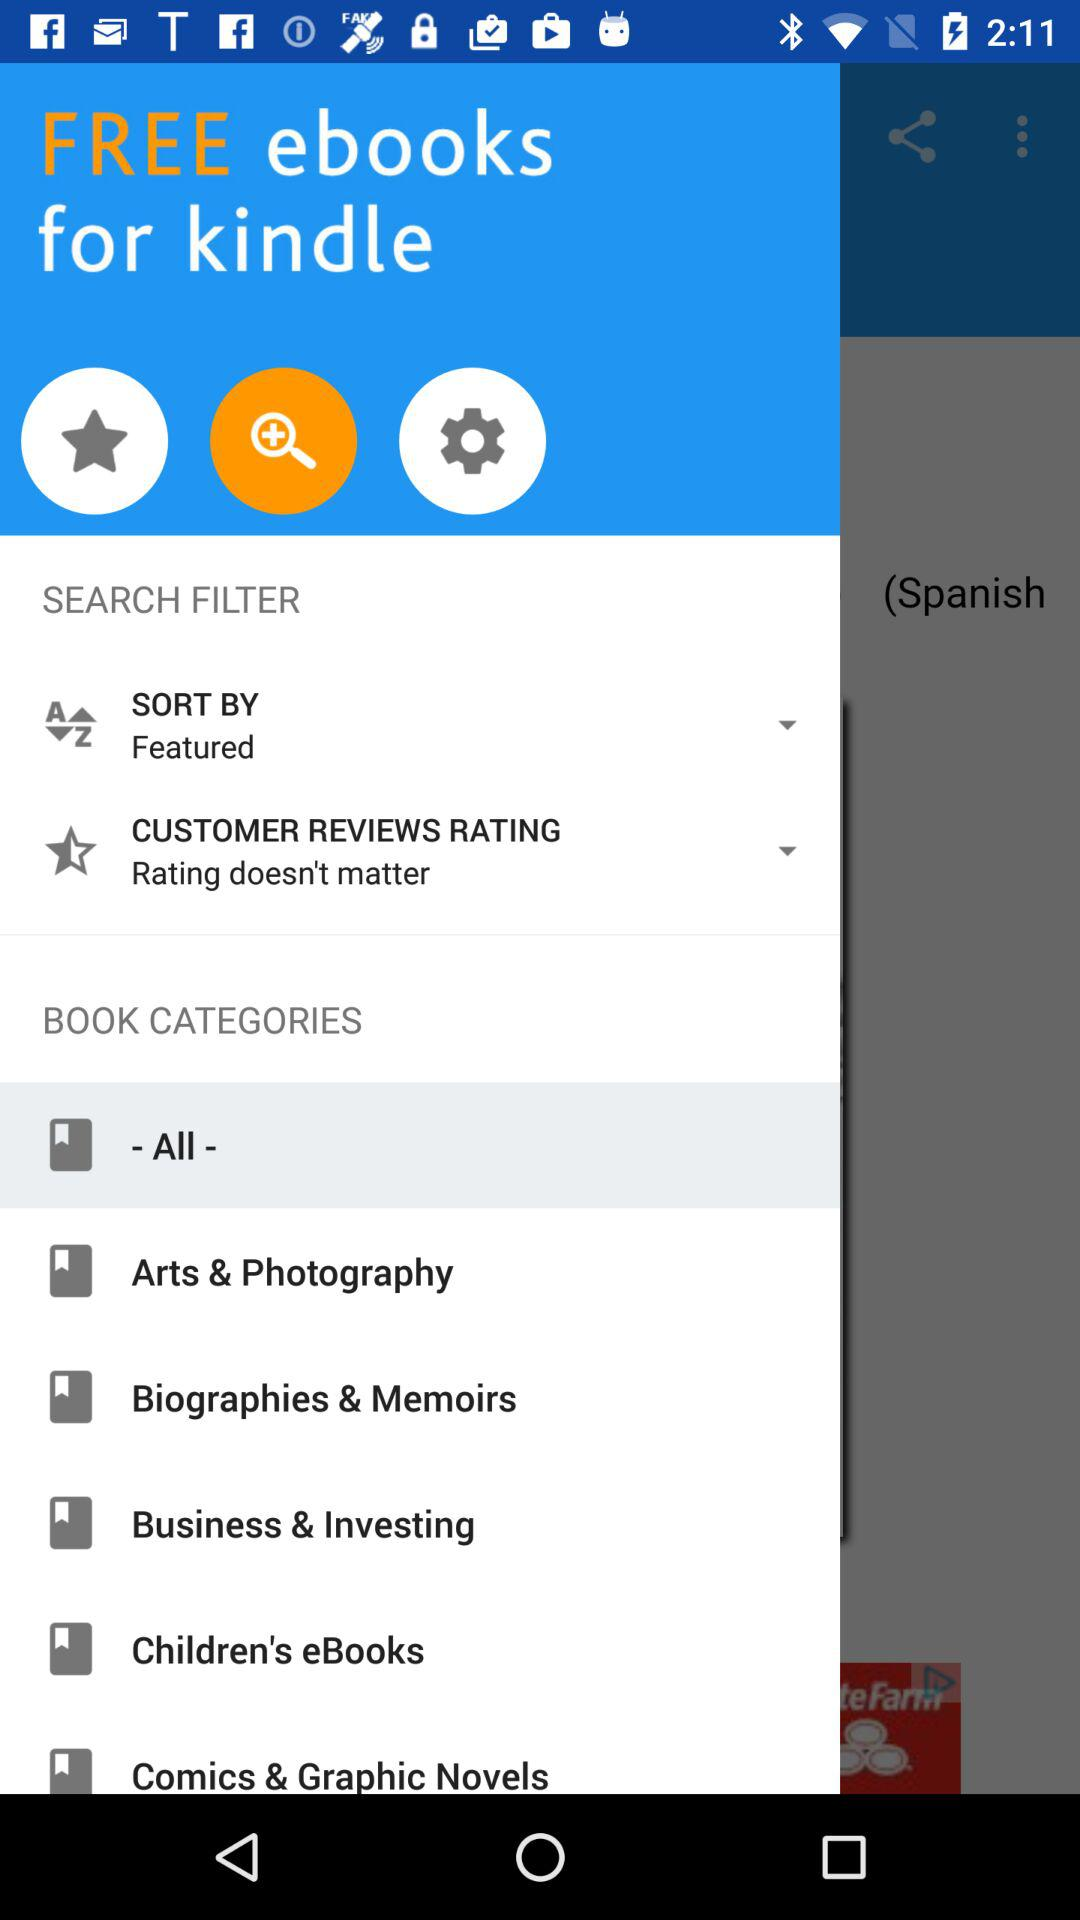What is the app name? The app name is "kindle". 